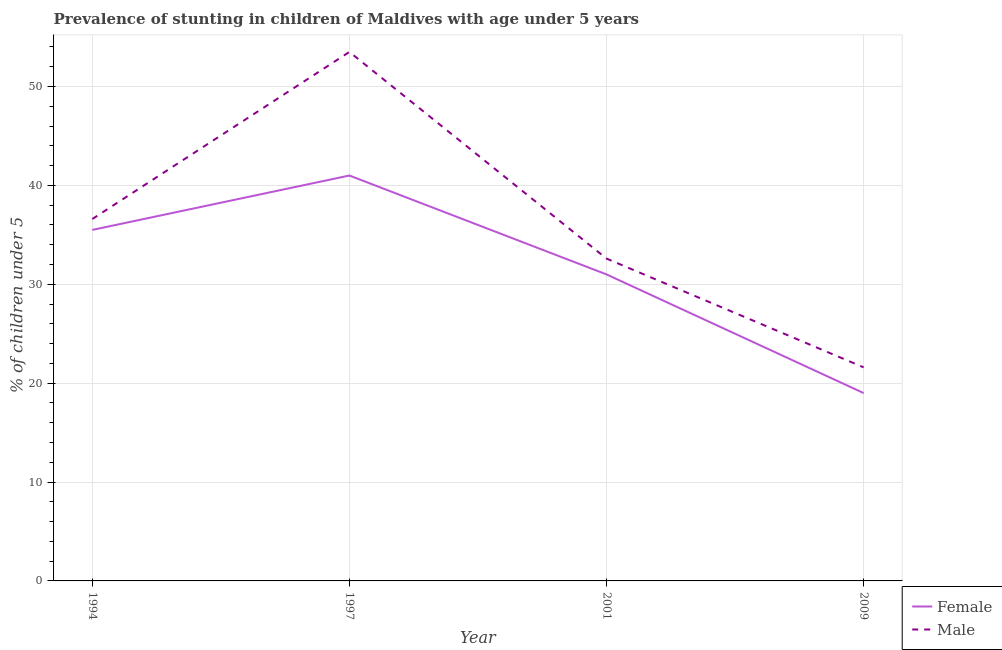How many different coloured lines are there?
Offer a terse response. 2. Does the line corresponding to percentage of stunted female children intersect with the line corresponding to percentage of stunted male children?
Your answer should be very brief. No. Is the number of lines equal to the number of legend labels?
Give a very brief answer. Yes. What is the percentage of stunted male children in 2009?
Keep it short and to the point. 21.6. Across all years, what is the maximum percentage of stunted male children?
Your answer should be compact. 53.5. Across all years, what is the minimum percentage of stunted female children?
Make the answer very short. 19. In which year was the percentage of stunted female children maximum?
Offer a terse response. 1997. In which year was the percentage of stunted female children minimum?
Your answer should be compact. 2009. What is the total percentage of stunted male children in the graph?
Offer a very short reply. 144.3. What is the difference between the percentage of stunted female children in 1994 and that in 2009?
Your response must be concise. 16.5. What is the difference between the percentage of stunted female children in 1994 and the percentage of stunted male children in 2001?
Offer a terse response. 2.9. What is the average percentage of stunted female children per year?
Ensure brevity in your answer.  31.62. In the year 2001, what is the difference between the percentage of stunted male children and percentage of stunted female children?
Your answer should be very brief. 1.6. What is the ratio of the percentage of stunted male children in 1994 to that in 1997?
Provide a short and direct response. 0.68. Is the percentage of stunted male children in 1997 less than that in 2009?
Make the answer very short. No. What is the difference between the highest and the second highest percentage of stunted male children?
Your answer should be very brief. 16.9. What is the difference between the highest and the lowest percentage of stunted male children?
Keep it short and to the point. 31.9. Is the percentage of stunted female children strictly less than the percentage of stunted male children over the years?
Your response must be concise. Yes. How many lines are there?
Your response must be concise. 2. What is the difference between two consecutive major ticks on the Y-axis?
Make the answer very short. 10. Are the values on the major ticks of Y-axis written in scientific E-notation?
Provide a succinct answer. No. How are the legend labels stacked?
Make the answer very short. Vertical. What is the title of the graph?
Offer a terse response. Prevalence of stunting in children of Maldives with age under 5 years. What is the label or title of the Y-axis?
Keep it short and to the point.  % of children under 5. What is the  % of children under 5 of Female in 1994?
Give a very brief answer. 35.5. What is the  % of children under 5 of Male in 1994?
Provide a succinct answer. 36.6. What is the  % of children under 5 of Female in 1997?
Offer a terse response. 41. What is the  % of children under 5 in Male in 1997?
Ensure brevity in your answer.  53.5. What is the  % of children under 5 of Male in 2001?
Your answer should be very brief. 32.6. What is the  % of children under 5 of Male in 2009?
Your answer should be very brief. 21.6. Across all years, what is the maximum  % of children under 5 in Female?
Give a very brief answer. 41. Across all years, what is the maximum  % of children under 5 in Male?
Give a very brief answer. 53.5. Across all years, what is the minimum  % of children under 5 of Male?
Give a very brief answer. 21.6. What is the total  % of children under 5 in Female in the graph?
Keep it short and to the point. 126.5. What is the total  % of children under 5 of Male in the graph?
Keep it short and to the point. 144.3. What is the difference between the  % of children under 5 of Male in 1994 and that in 1997?
Provide a short and direct response. -16.9. What is the difference between the  % of children under 5 in Male in 1994 and that in 2001?
Give a very brief answer. 4. What is the difference between the  % of children under 5 in Male in 1994 and that in 2009?
Make the answer very short. 15. What is the difference between the  % of children under 5 in Female in 1997 and that in 2001?
Keep it short and to the point. 10. What is the difference between the  % of children under 5 in Male in 1997 and that in 2001?
Make the answer very short. 20.9. What is the difference between the  % of children under 5 of Male in 1997 and that in 2009?
Provide a succinct answer. 31.9. What is the difference between the  % of children under 5 in Female in 1994 and the  % of children under 5 in Male in 1997?
Your response must be concise. -18. What is the difference between the  % of children under 5 in Female in 1994 and the  % of children under 5 in Male in 2001?
Keep it short and to the point. 2.9. What is the difference between the  % of children under 5 of Female in 1997 and the  % of children under 5 of Male in 2001?
Provide a succinct answer. 8.4. What is the difference between the  % of children under 5 of Female in 1997 and the  % of children under 5 of Male in 2009?
Keep it short and to the point. 19.4. What is the average  % of children under 5 of Female per year?
Ensure brevity in your answer.  31.62. What is the average  % of children under 5 in Male per year?
Your response must be concise. 36.08. In the year 1994, what is the difference between the  % of children under 5 of Female and  % of children under 5 of Male?
Provide a short and direct response. -1.1. In the year 1997, what is the difference between the  % of children under 5 of Female and  % of children under 5 of Male?
Your answer should be compact. -12.5. In the year 2009, what is the difference between the  % of children under 5 of Female and  % of children under 5 of Male?
Provide a succinct answer. -2.6. What is the ratio of the  % of children under 5 in Female in 1994 to that in 1997?
Offer a terse response. 0.87. What is the ratio of the  % of children under 5 in Male in 1994 to that in 1997?
Make the answer very short. 0.68. What is the ratio of the  % of children under 5 in Female in 1994 to that in 2001?
Provide a short and direct response. 1.15. What is the ratio of the  % of children under 5 of Male in 1994 to that in 2001?
Your response must be concise. 1.12. What is the ratio of the  % of children under 5 of Female in 1994 to that in 2009?
Your answer should be compact. 1.87. What is the ratio of the  % of children under 5 in Male in 1994 to that in 2009?
Keep it short and to the point. 1.69. What is the ratio of the  % of children under 5 of Female in 1997 to that in 2001?
Your answer should be very brief. 1.32. What is the ratio of the  % of children under 5 in Male in 1997 to that in 2001?
Keep it short and to the point. 1.64. What is the ratio of the  % of children under 5 of Female in 1997 to that in 2009?
Your answer should be very brief. 2.16. What is the ratio of the  % of children under 5 in Male in 1997 to that in 2009?
Provide a succinct answer. 2.48. What is the ratio of the  % of children under 5 in Female in 2001 to that in 2009?
Give a very brief answer. 1.63. What is the ratio of the  % of children under 5 in Male in 2001 to that in 2009?
Provide a succinct answer. 1.51. What is the difference between the highest and the second highest  % of children under 5 in Male?
Provide a short and direct response. 16.9. What is the difference between the highest and the lowest  % of children under 5 in Male?
Keep it short and to the point. 31.9. 